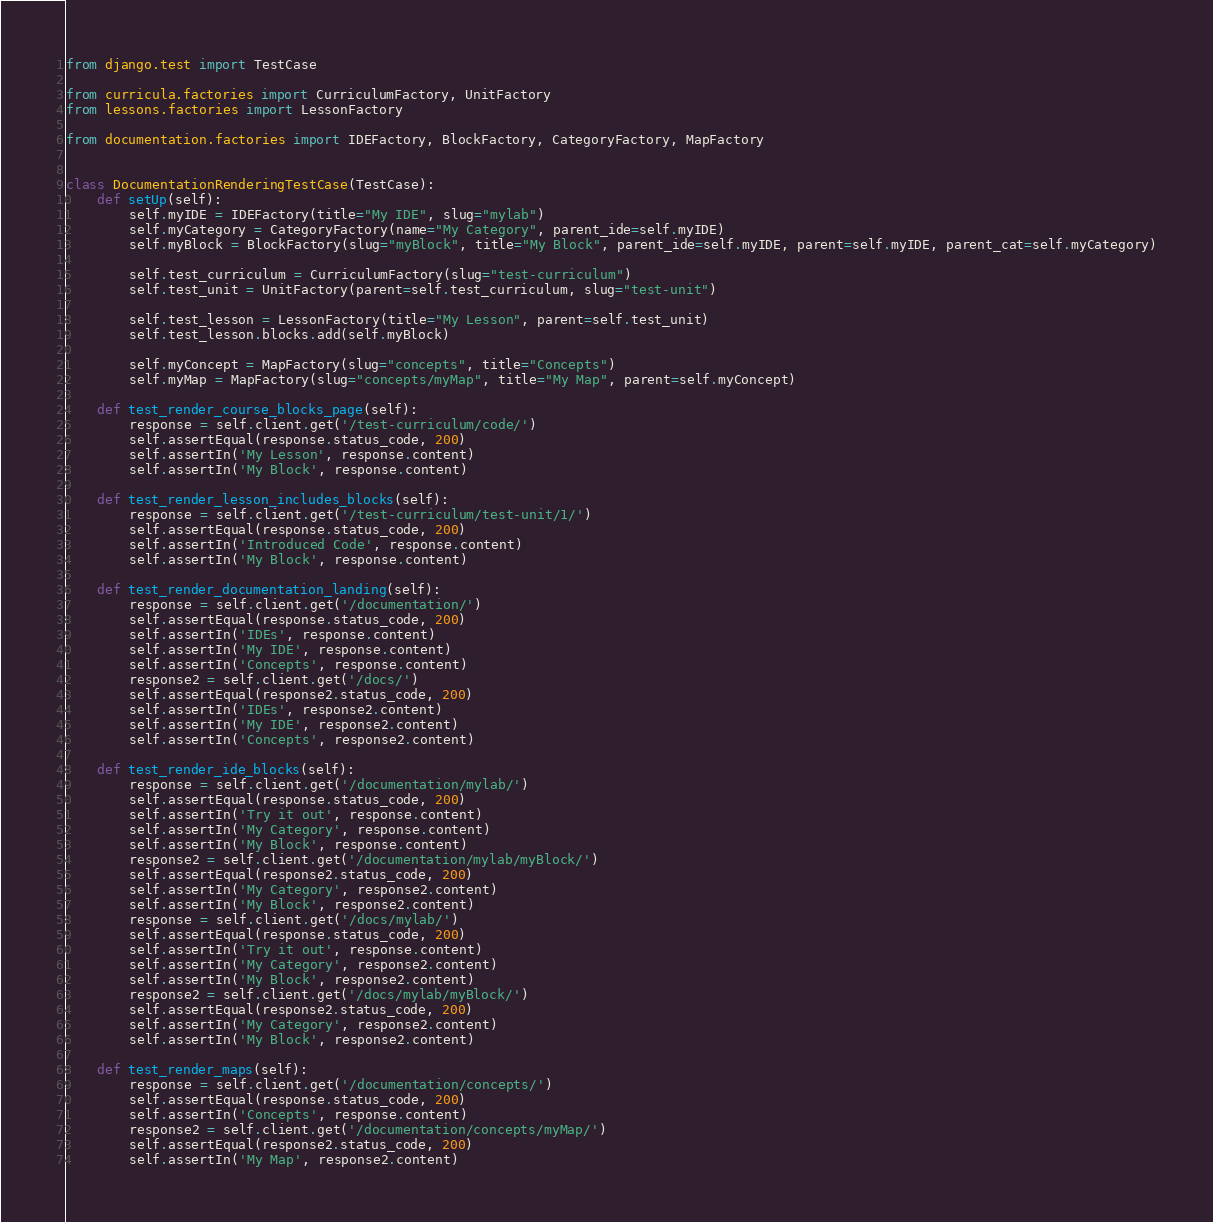Convert code to text. <code><loc_0><loc_0><loc_500><loc_500><_Python_>from django.test import TestCase

from curricula.factories import CurriculumFactory, UnitFactory
from lessons.factories import LessonFactory

from documentation.factories import IDEFactory, BlockFactory, CategoryFactory, MapFactory


class DocumentationRenderingTestCase(TestCase):
    def setUp(self):
        self.myIDE = IDEFactory(title="My IDE", slug="mylab")
        self.myCategory = CategoryFactory(name="My Category", parent_ide=self.myIDE)
        self.myBlock = BlockFactory(slug="myBlock", title="My Block", parent_ide=self.myIDE, parent=self.myIDE, parent_cat=self.myCategory)

        self.test_curriculum = CurriculumFactory(slug="test-curriculum")
        self.test_unit = UnitFactory(parent=self.test_curriculum, slug="test-unit")

        self.test_lesson = LessonFactory(title="My Lesson", parent=self.test_unit)
        self.test_lesson.blocks.add(self.myBlock)

        self.myConcept = MapFactory(slug="concepts", title="Concepts")
        self.myMap = MapFactory(slug="concepts/myMap", title="My Map", parent=self.myConcept)

    def test_render_course_blocks_page(self):
        response = self.client.get('/test-curriculum/code/')
        self.assertEqual(response.status_code, 200)
        self.assertIn('My Lesson', response.content)
        self.assertIn('My Block', response.content)

    def test_render_lesson_includes_blocks(self):
        response = self.client.get('/test-curriculum/test-unit/1/')
        self.assertEqual(response.status_code, 200)
        self.assertIn('Introduced Code', response.content)
        self.assertIn('My Block', response.content)

    def test_render_documentation_landing(self):
        response = self.client.get('/documentation/')
        self.assertEqual(response.status_code, 200)
        self.assertIn('IDEs', response.content)
        self.assertIn('My IDE', response.content)
        self.assertIn('Concepts', response.content)
        response2 = self.client.get('/docs/')
        self.assertEqual(response2.status_code, 200)
        self.assertIn('IDEs', response2.content)
        self.assertIn('My IDE', response2.content)
        self.assertIn('Concepts', response2.content)

    def test_render_ide_blocks(self):
        response = self.client.get('/documentation/mylab/')
        self.assertEqual(response.status_code, 200)
        self.assertIn('Try it out', response.content)
        self.assertIn('My Category', response.content)
        self.assertIn('My Block', response.content)
        response2 = self.client.get('/documentation/mylab/myBlock/')
        self.assertEqual(response2.status_code, 200)
        self.assertIn('My Category', response2.content)
        self.assertIn('My Block', response2.content)
        response = self.client.get('/docs/mylab/')
        self.assertEqual(response.status_code, 200)
        self.assertIn('Try it out', response.content)
        self.assertIn('My Category', response2.content)
        self.assertIn('My Block', response2.content)
        response2 = self.client.get('/docs/mylab/myBlock/')
        self.assertEqual(response2.status_code, 200)
        self.assertIn('My Category', response2.content)
        self.assertIn('My Block', response2.content)

    def test_render_maps(self):
        response = self.client.get('/documentation/concepts/')
        self.assertEqual(response.status_code, 200)
        self.assertIn('Concepts', response.content)
        response2 = self.client.get('/documentation/concepts/myMap/')
        self.assertEqual(response2.status_code, 200)
        self.assertIn('My Map', response2.content)</code> 